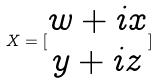Convert formula to latex. <formula><loc_0><loc_0><loc_500><loc_500>X = [ \begin{matrix} w + i x \\ y + i z \end{matrix} ]</formula> 